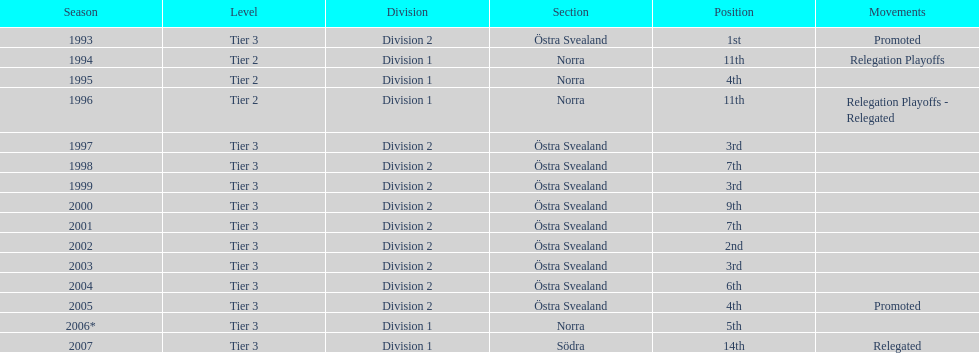Would you mind parsing the complete table? {'header': ['Season', 'Level', 'Division', 'Section', 'Position', 'Movements'], 'rows': [['1993', 'Tier 3', 'Division 2', 'Östra Svealand', '1st', 'Promoted'], ['1994', 'Tier 2', 'Division 1', 'Norra', '11th', 'Relegation Playoffs'], ['1995', 'Tier 2', 'Division 1', 'Norra', '4th', ''], ['1996', 'Tier 2', 'Division 1', 'Norra', '11th', 'Relegation Playoffs - Relegated'], ['1997', 'Tier 3', 'Division 2', 'Östra Svealand', '3rd', ''], ['1998', 'Tier 3', 'Division 2', 'Östra Svealand', '7th', ''], ['1999', 'Tier 3', 'Division 2', 'Östra Svealand', '3rd', ''], ['2000', 'Tier 3', 'Division 2', 'Östra Svealand', '9th', ''], ['2001', 'Tier 3', 'Division 2', 'Östra Svealand', '7th', ''], ['2002', 'Tier 3', 'Division 2', 'Östra Svealand', '2nd', ''], ['2003', 'Tier 3', 'Division 2', 'Östra Svealand', '3rd', ''], ['2004', 'Tier 3', 'Division 2', 'Östra Svealand', '6th', ''], ['2005', 'Tier 3', 'Division 2', 'Östra Svealand', '4th', 'Promoted'], ['2006*', 'Tier 3', 'Division 1', 'Norra', '5th', ''], ['2007', 'Tier 3', 'Division 1', 'Södra', '14th', 'Relegated']]} What is mentioned under the movements column of the previous season? Relegated. 